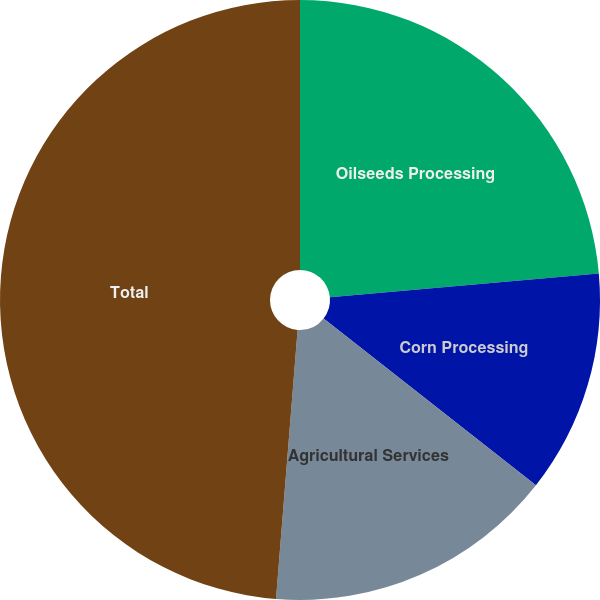Convert chart. <chart><loc_0><loc_0><loc_500><loc_500><pie_chart><fcel>Oilseeds Processing<fcel>Corn Processing<fcel>Agricultural Services<fcel>Total<nl><fcel>23.59%<fcel>12.01%<fcel>15.68%<fcel>48.73%<nl></chart> 